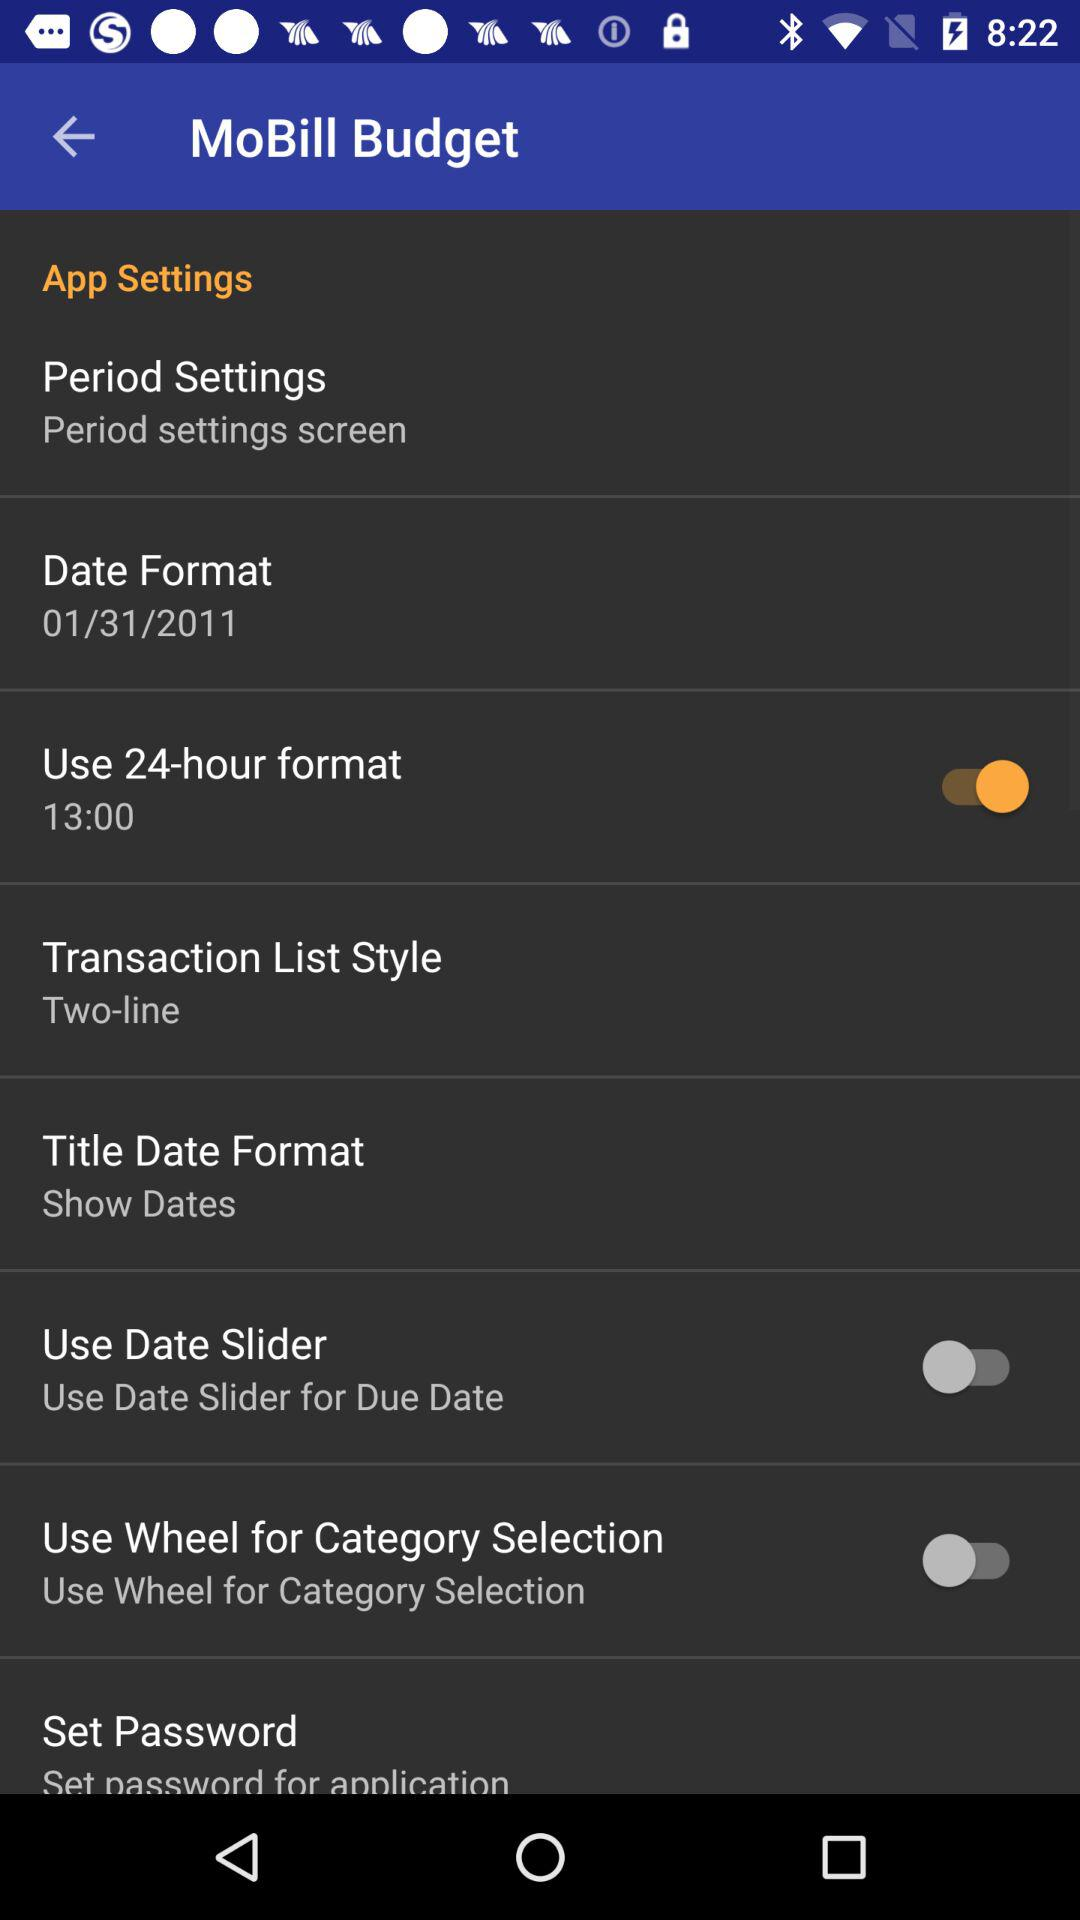Which date is mentioned in "Date Format"? The mentioned date is January 31, 2011. 